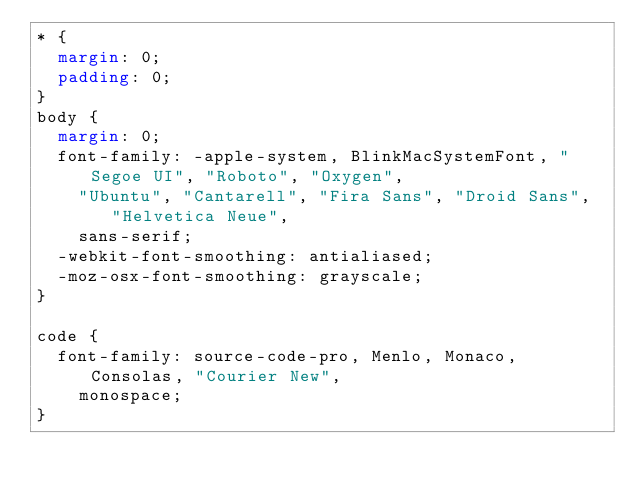<code> <loc_0><loc_0><loc_500><loc_500><_CSS_>* {
  margin: 0;
  padding: 0;
}
body {
  margin: 0;
  font-family: -apple-system, BlinkMacSystemFont, "Segoe UI", "Roboto", "Oxygen",
    "Ubuntu", "Cantarell", "Fira Sans", "Droid Sans", "Helvetica Neue",
    sans-serif;
  -webkit-font-smoothing: antialiased;
  -moz-osx-font-smoothing: grayscale;
}

code {
  font-family: source-code-pro, Menlo, Monaco, Consolas, "Courier New",
    monospace;
}
</code> 